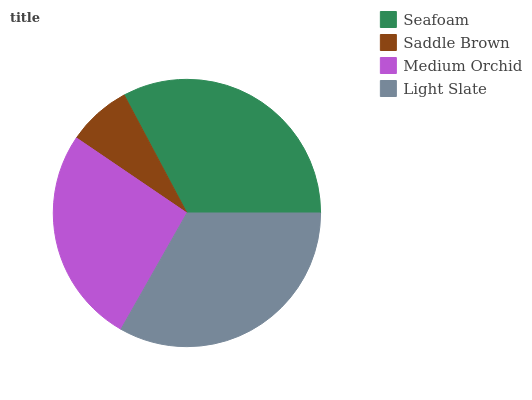Is Saddle Brown the minimum?
Answer yes or no. Yes. Is Light Slate the maximum?
Answer yes or no. Yes. Is Medium Orchid the minimum?
Answer yes or no. No. Is Medium Orchid the maximum?
Answer yes or no. No. Is Medium Orchid greater than Saddle Brown?
Answer yes or no. Yes. Is Saddle Brown less than Medium Orchid?
Answer yes or no. Yes. Is Saddle Brown greater than Medium Orchid?
Answer yes or no. No. Is Medium Orchid less than Saddle Brown?
Answer yes or no. No. Is Seafoam the high median?
Answer yes or no. Yes. Is Medium Orchid the low median?
Answer yes or no. Yes. Is Saddle Brown the high median?
Answer yes or no. No. Is Saddle Brown the low median?
Answer yes or no. No. 